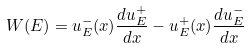<formula> <loc_0><loc_0><loc_500><loc_500>W ( E ) = u ^ { - } _ { E } ( x ) \frac { d u ^ { + } _ { E } } { d x } - u ^ { + } _ { E } ( x ) \frac { d u ^ { - } _ { E } } { d x }</formula> 